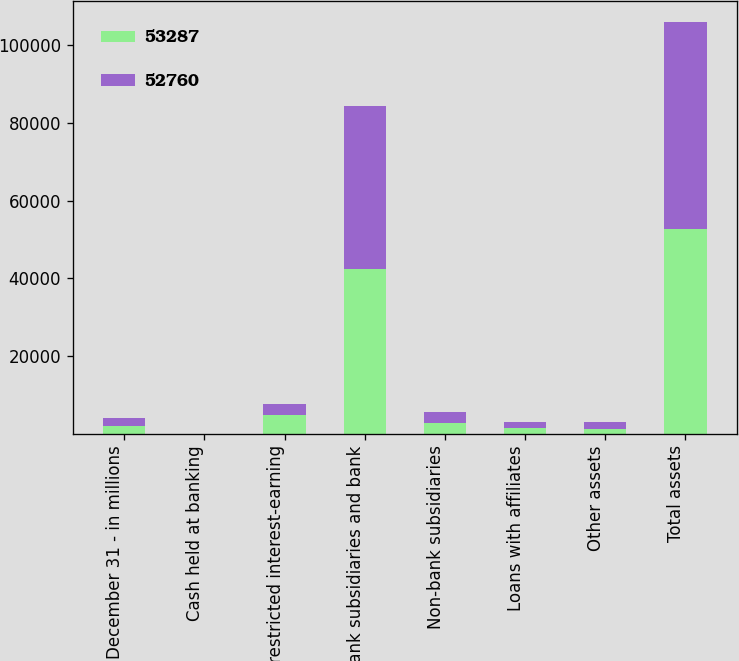Convert chart to OTSL. <chart><loc_0><loc_0><loc_500><loc_500><stacked_bar_chart><ecel><fcel>December 31 - in millions<fcel>Cash held at banking<fcel>Nonrestricted interest-earning<fcel>Bank subsidiaries and bank<fcel>Non-bank subsidiaries<fcel>Loans with affiliates<fcel>Other assets<fcel>Total assets<nl><fcel>53287<fcel>2016<fcel>1<fcel>4684<fcel>42361<fcel>2859<fcel>1358<fcel>1322<fcel>52760<nl><fcel>52760<fcel>2015<fcel>1<fcel>3077<fcel>41919<fcel>2747<fcel>1669<fcel>1724<fcel>53287<nl></chart> 